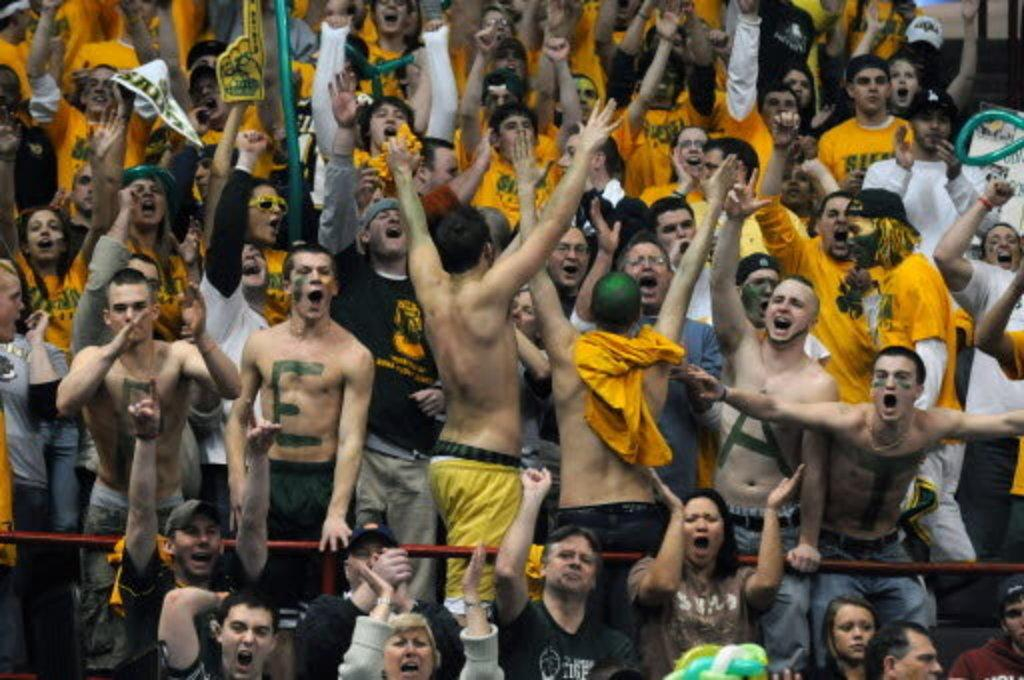What is the main subject of the image? The main subject of the image is a crowd of people. What are the people in the image doing? The people are standing and raising their hands up. Can you describe the people's actions in more detail? It appears that the people are shouting. Where is the grandmother sitting in the image? There is no grandmother present in the image. Can you tell me how many streams are visible in the image? There are no streams visible in the image; it features a crowd of people standing and raising their hands up. 